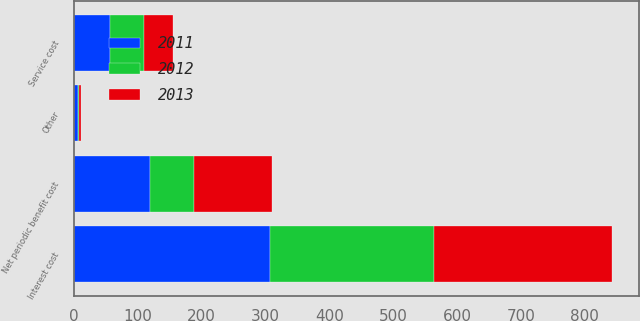Convert chart. <chart><loc_0><loc_0><loc_500><loc_500><stacked_bar_chart><ecel><fcel>Service cost<fcel>Interest cost<fcel>Other<fcel>Net periodic benefit cost<nl><fcel>2012<fcel>53<fcel>257<fcel>1<fcel>69<nl><fcel>2013<fcel>45<fcel>279<fcel>4<fcel>122<nl><fcel>2011<fcel>57<fcel>307<fcel>6<fcel>119<nl></chart> 